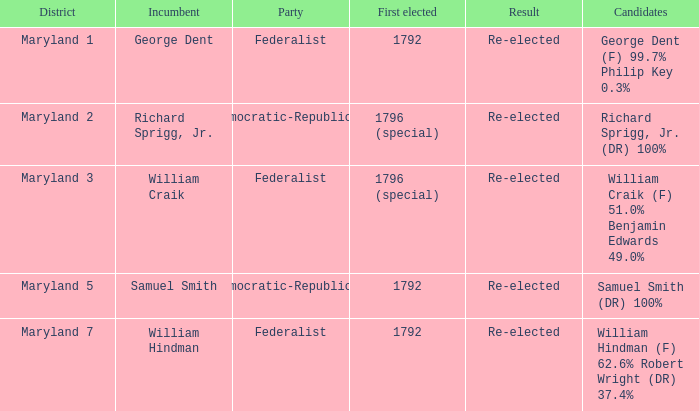What is the party when the incumbent is samuel smith? Democratic-Republican. Parse the full table. {'header': ['District', 'Incumbent', 'Party', 'First elected', 'Result', 'Candidates'], 'rows': [['Maryland 1', 'George Dent', 'Federalist', '1792', 'Re-elected', 'George Dent (F) 99.7% Philip Key 0.3%'], ['Maryland 2', 'Richard Sprigg, Jr.', 'Democratic-Republican', '1796 (special)', 'Re-elected', 'Richard Sprigg, Jr. (DR) 100%'], ['Maryland 3', 'William Craik', 'Federalist', '1796 (special)', 'Re-elected', 'William Craik (F) 51.0% Benjamin Edwards 49.0%'], ['Maryland 5', 'Samuel Smith', 'Democratic-Republican', '1792', 'Re-elected', 'Samuel Smith (DR) 100%'], ['Maryland 7', 'William Hindman', 'Federalist', '1792', 'Re-elected', 'William Hindman (F) 62.6% Robert Wright (DR) 37.4%']]} 